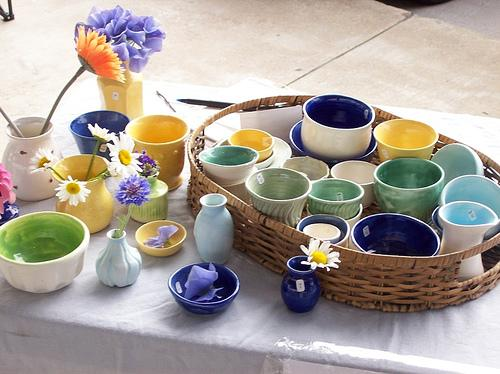How many of the vases are made from something other than glass? all 